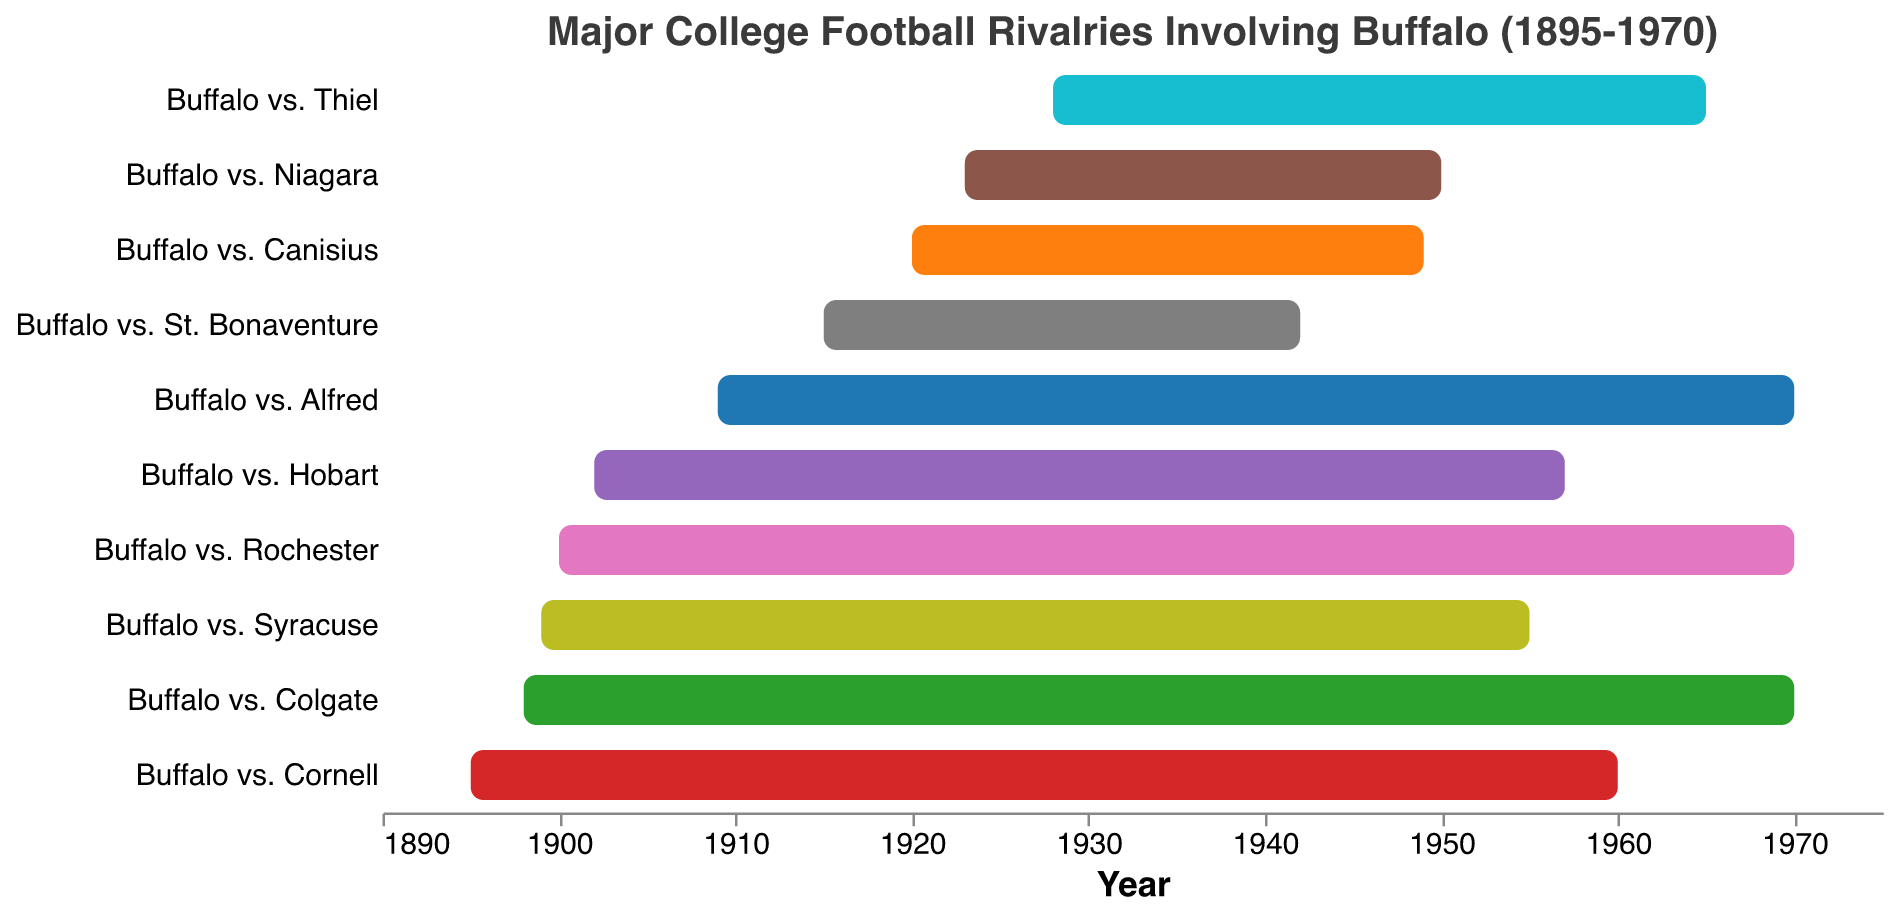What is the time span of the rivalry between Buffalo and Colgate? To find the time span, subtract the start year from the end year. The rivalry between Buffalo and Colgate started in 1898 and ended in 1970. Therefore, the time span is 1970 - 1898.
Answer: 72 years Which rivalry had the shortest duration? Look for the rivalry with the smallest difference between the start and end years. The rivalry between Buffalo and St. Bonaventure lasted from 1915 to 1942, which is a duration of 27 years.
Answer: Buffalo vs. St. Bonaventure Between which years do all rivalries take place? Identify the earliest start year and latest end year among all rivalries. The earliest start year is 1895 (Buffalo vs. Cornell), and the latest end year is 1970 (multiple rivalries).
Answer: 1895 to 1970 Which rivalry involving Buffalo had the longest uninterrupted duration in the 20th century? Look at the Start Year and End Year for each rivalry and calculate the duration. The rivalry between Buffalo and Colgate lasted 72 years, which is the longest among all listed.
Answer: Buffalo vs. Colgate What is the average duration of all listed rivalries? Calculate each rivalry's duration, sum them up, and then divide by the number of rivalries. There are 10 rivalries total. The durations are 65, 72, 56, 29, 27, 55, 70, 27, 37, and 61 years, respectively. Sum these and divide by 10. (65 + 72 + 56 + 29 + 27 + 55 + 70 + 27 + 37 + 61) / 10 = 499 / 10.
Answer: 49.9 years Which rivalry ended first? Look for the rivalry with the earliest end year. The rivalry between Buffalo and St. Bonaventure ended in 1942, which is earlier than any other listed end year.
Answer: Buffalo vs. St. Bonaventure How many rivalries began before 1910? Count the number of rivalries with a start year before 1910. The rivalries meeting this criterion are: Buffalo vs. Cornell, Buffalo vs. Colgate, Buffalo vs. Syracuse, Buffalo vs. Hobart, Buffalo vs. Rochester, and Buffalo vs. Alfred; totaling 6.
Answer: 6 rivalries 